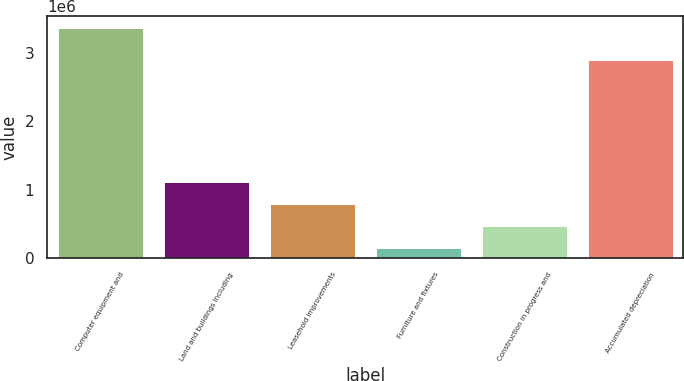Convert chart. <chart><loc_0><loc_0><loc_500><loc_500><bar_chart><fcel>Computer equipment and<fcel>Land and buildings including<fcel>Leasehold improvements<fcel>Furniture and fixtures<fcel>Construction in progress and<fcel>Accumulated depreciation<nl><fcel>3.36901e+06<fcel>1.11545e+06<fcel>793509<fcel>149633<fcel>471571<fcel>2.89057e+06<nl></chart> 